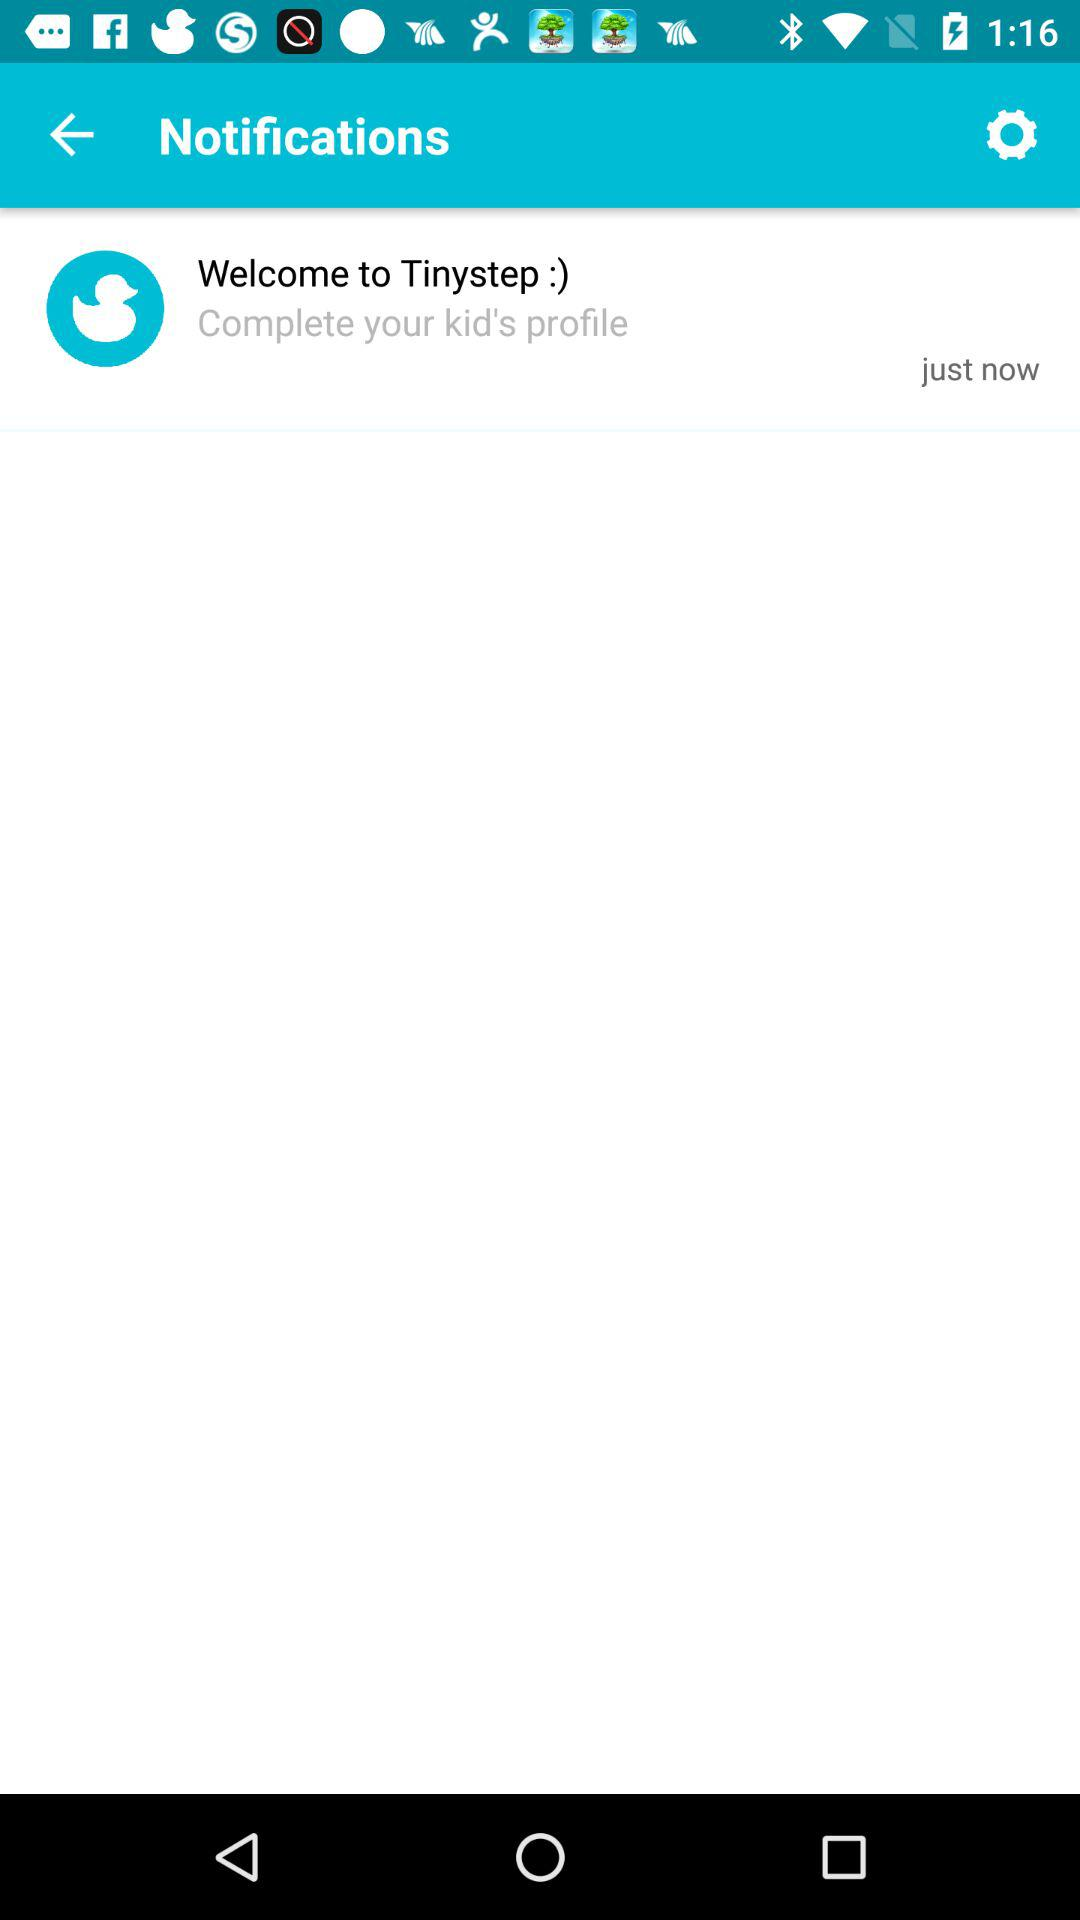What is the name of the application? The name of the application is "Tinystep". 